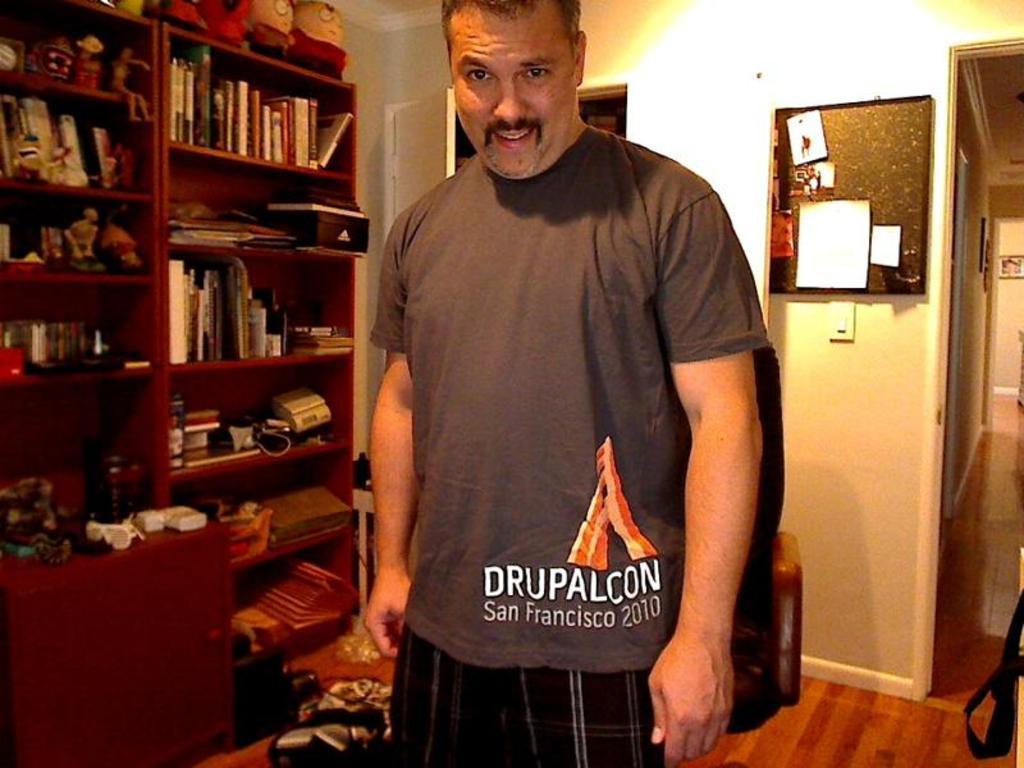Describe this image in one or two sentences. In the middle of the image a person is standing and smiling. Behind him we can see some chairs and wall, on the wall we can see a door and cupboard. In the cupboard we can see some books, toys and we can see a board and frames. 